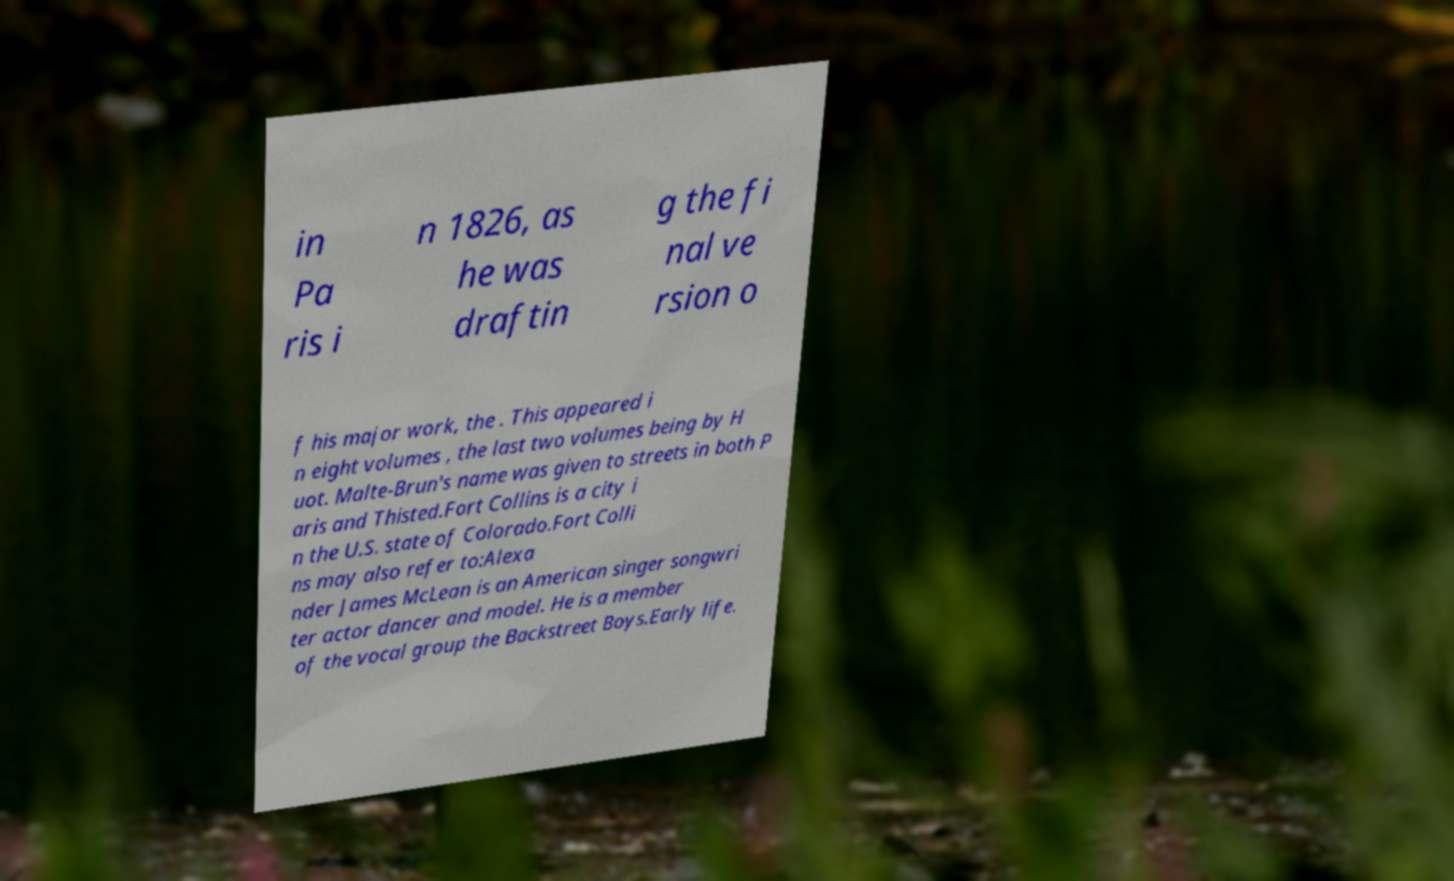For documentation purposes, I need the text within this image transcribed. Could you provide that? in Pa ris i n 1826, as he was draftin g the fi nal ve rsion o f his major work, the . This appeared i n eight volumes , the last two volumes being by H uot. Malte-Brun's name was given to streets in both P aris and Thisted.Fort Collins is a city i n the U.S. state of Colorado.Fort Colli ns may also refer to:Alexa nder James McLean is an American singer songwri ter actor dancer and model. He is a member of the vocal group the Backstreet Boys.Early life. 